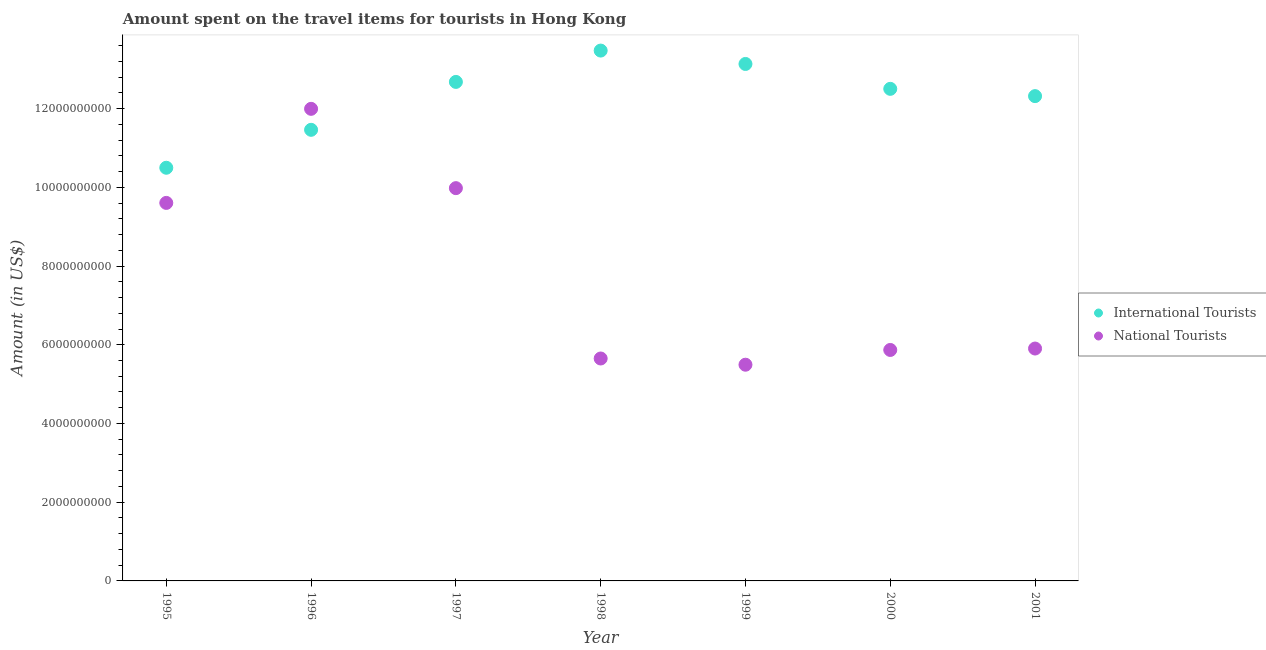How many different coloured dotlines are there?
Make the answer very short. 2. What is the amount spent on travel items of national tourists in 1998?
Give a very brief answer. 5.65e+09. Across all years, what is the maximum amount spent on travel items of national tourists?
Offer a very short reply. 1.20e+1. Across all years, what is the minimum amount spent on travel items of international tourists?
Offer a terse response. 1.05e+1. What is the total amount spent on travel items of international tourists in the graph?
Your answer should be compact. 8.61e+1. What is the difference between the amount spent on travel items of national tourists in 1996 and that in 2000?
Provide a short and direct response. 6.13e+09. What is the difference between the amount spent on travel items of national tourists in 2001 and the amount spent on travel items of international tourists in 1996?
Keep it short and to the point. -5.56e+09. What is the average amount spent on travel items of international tourists per year?
Keep it short and to the point. 1.23e+1. In the year 1999, what is the difference between the amount spent on travel items of national tourists and amount spent on travel items of international tourists?
Give a very brief answer. -7.64e+09. What is the ratio of the amount spent on travel items of international tourists in 1996 to that in 2000?
Provide a succinct answer. 0.92. Is the amount spent on travel items of international tourists in 1997 less than that in 1999?
Make the answer very short. Yes. What is the difference between the highest and the second highest amount spent on travel items of national tourists?
Give a very brief answer. 2.02e+09. What is the difference between the highest and the lowest amount spent on travel items of national tourists?
Your response must be concise. 6.50e+09. Is the sum of the amount spent on travel items of national tourists in 1995 and 1996 greater than the maximum amount spent on travel items of international tourists across all years?
Your response must be concise. Yes. Is the amount spent on travel items of national tourists strictly less than the amount spent on travel items of international tourists over the years?
Offer a terse response. No. How many years are there in the graph?
Your response must be concise. 7. What is the difference between two consecutive major ticks on the Y-axis?
Your response must be concise. 2.00e+09. Does the graph contain any zero values?
Make the answer very short. No. How many legend labels are there?
Your response must be concise. 2. What is the title of the graph?
Give a very brief answer. Amount spent on the travel items for tourists in Hong Kong. What is the Amount (in US$) in International Tourists in 1995?
Offer a very short reply. 1.05e+1. What is the Amount (in US$) in National Tourists in 1995?
Your answer should be compact. 9.60e+09. What is the Amount (in US$) in International Tourists in 1996?
Ensure brevity in your answer.  1.15e+1. What is the Amount (in US$) of National Tourists in 1996?
Keep it short and to the point. 1.20e+1. What is the Amount (in US$) in International Tourists in 1997?
Ensure brevity in your answer.  1.27e+1. What is the Amount (in US$) of National Tourists in 1997?
Provide a succinct answer. 9.98e+09. What is the Amount (in US$) of International Tourists in 1998?
Offer a terse response. 1.35e+1. What is the Amount (in US$) in National Tourists in 1998?
Ensure brevity in your answer.  5.65e+09. What is the Amount (in US$) of International Tourists in 1999?
Offer a terse response. 1.31e+1. What is the Amount (in US$) in National Tourists in 1999?
Make the answer very short. 5.49e+09. What is the Amount (in US$) of International Tourists in 2000?
Ensure brevity in your answer.  1.25e+1. What is the Amount (in US$) of National Tourists in 2000?
Keep it short and to the point. 5.87e+09. What is the Amount (in US$) in International Tourists in 2001?
Give a very brief answer. 1.23e+1. What is the Amount (in US$) of National Tourists in 2001?
Your answer should be compact. 5.90e+09. Across all years, what is the maximum Amount (in US$) of International Tourists?
Your answer should be very brief. 1.35e+1. Across all years, what is the maximum Amount (in US$) of National Tourists?
Your answer should be very brief. 1.20e+1. Across all years, what is the minimum Amount (in US$) in International Tourists?
Provide a short and direct response. 1.05e+1. Across all years, what is the minimum Amount (in US$) in National Tourists?
Give a very brief answer. 5.49e+09. What is the total Amount (in US$) of International Tourists in the graph?
Make the answer very short. 8.61e+1. What is the total Amount (in US$) in National Tourists in the graph?
Provide a succinct answer. 5.45e+1. What is the difference between the Amount (in US$) in International Tourists in 1995 and that in 1996?
Offer a very short reply. -9.64e+08. What is the difference between the Amount (in US$) in National Tourists in 1995 and that in 1996?
Keep it short and to the point. -2.39e+09. What is the difference between the Amount (in US$) in International Tourists in 1995 and that in 1997?
Keep it short and to the point. -2.18e+09. What is the difference between the Amount (in US$) of National Tourists in 1995 and that in 1997?
Your answer should be very brief. -3.75e+08. What is the difference between the Amount (in US$) of International Tourists in 1995 and that in 1998?
Your response must be concise. -2.98e+09. What is the difference between the Amount (in US$) of National Tourists in 1995 and that in 1998?
Your answer should be very brief. 3.95e+09. What is the difference between the Amount (in US$) in International Tourists in 1995 and that in 1999?
Keep it short and to the point. -2.64e+09. What is the difference between the Amount (in US$) of National Tourists in 1995 and that in 1999?
Your response must be concise. 4.11e+09. What is the difference between the Amount (in US$) of International Tourists in 1995 and that in 2000?
Make the answer very short. -2.00e+09. What is the difference between the Amount (in US$) of National Tourists in 1995 and that in 2000?
Your answer should be very brief. 3.74e+09. What is the difference between the Amount (in US$) of International Tourists in 1995 and that in 2001?
Provide a succinct answer. -1.82e+09. What is the difference between the Amount (in US$) in National Tourists in 1995 and that in 2001?
Keep it short and to the point. 3.70e+09. What is the difference between the Amount (in US$) in International Tourists in 1996 and that in 1997?
Your answer should be very brief. -1.22e+09. What is the difference between the Amount (in US$) of National Tourists in 1996 and that in 1997?
Make the answer very short. 2.02e+09. What is the difference between the Amount (in US$) of International Tourists in 1996 and that in 1998?
Offer a terse response. -2.01e+09. What is the difference between the Amount (in US$) in National Tourists in 1996 and that in 1998?
Offer a terse response. 6.34e+09. What is the difference between the Amount (in US$) of International Tourists in 1996 and that in 1999?
Your answer should be very brief. -1.67e+09. What is the difference between the Amount (in US$) of National Tourists in 1996 and that in 1999?
Provide a short and direct response. 6.50e+09. What is the difference between the Amount (in US$) in International Tourists in 1996 and that in 2000?
Your response must be concise. -1.04e+09. What is the difference between the Amount (in US$) in National Tourists in 1996 and that in 2000?
Your answer should be compact. 6.13e+09. What is the difference between the Amount (in US$) of International Tourists in 1996 and that in 2001?
Offer a terse response. -8.56e+08. What is the difference between the Amount (in US$) in National Tourists in 1996 and that in 2001?
Offer a terse response. 6.09e+09. What is the difference between the Amount (in US$) of International Tourists in 1997 and that in 1998?
Provide a short and direct response. -7.96e+08. What is the difference between the Amount (in US$) in National Tourists in 1997 and that in 1998?
Provide a short and direct response. 4.33e+09. What is the difference between the Amount (in US$) in International Tourists in 1997 and that in 1999?
Offer a terse response. -4.56e+08. What is the difference between the Amount (in US$) in National Tourists in 1997 and that in 1999?
Your response must be concise. 4.49e+09. What is the difference between the Amount (in US$) in International Tourists in 1997 and that in 2000?
Ensure brevity in your answer.  1.76e+08. What is the difference between the Amount (in US$) of National Tourists in 1997 and that in 2000?
Provide a succinct answer. 4.11e+09. What is the difference between the Amount (in US$) of International Tourists in 1997 and that in 2001?
Ensure brevity in your answer.  3.61e+08. What is the difference between the Amount (in US$) of National Tourists in 1997 and that in 2001?
Your response must be concise. 4.08e+09. What is the difference between the Amount (in US$) in International Tourists in 1998 and that in 1999?
Keep it short and to the point. 3.40e+08. What is the difference between the Amount (in US$) in National Tourists in 1998 and that in 1999?
Offer a very short reply. 1.58e+08. What is the difference between the Amount (in US$) of International Tourists in 1998 and that in 2000?
Provide a succinct answer. 9.72e+08. What is the difference between the Amount (in US$) in National Tourists in 1998 and that in 2000?
Ensure brevity in your answer.  -2.17e+08. What is the difference between the Amount (in US$) in International Tourists in 1998 and that in 2001?
Keep it short and to the point. 1.16e+09. What is the difference between the Amount (in US$) of National Tourists in 1998 and that in 2001?
Your response must be concise. -2.53e+08. What is the difference between the Amount (in US$) of International Tourists in 1999 and that in 2000?
Your answer should be compact. 6.32e+08. What is the difference between the Amount (in US$) in National Tourists in 1999 and that in 2000?
Give a very brief answer. -3.75e+08. What is the difference between the Amount (in US$) of International Tourists in 1999 and that in 2001?
Your response must be concise. 8.17e+08. What is the difference between the Amount (in US$) in National Tourists in 1999 and that in 2001?
Your answer should be very brief. -4.11e+08. What is the difference between the Amount (in US$) of International Tourists in 2000 and that in 2001?
Ensure brevity in your answer.  1.85e+08. What is the difference between the Amount (in US$) of National Tourists in 2000 and that in 2001?
Ensure brevity in your answer.  -3.60e+07. What is the difference between the Amount (in US$) of International Tourists in 1995 and the Amount (in US$) of National Tourists in 1996?
Your answer should be very brief. -1.50e+09. What is the difference between the Amount (in US$) of International Tourists in 1995 and the Amount (in US$) of National Tourists in 1997?
Your response must be concise. 5.18e+08. What is the difference between the Amount (in US$) in International Tourists in 1995 and the Amount (in US$) in National Tourists in 1998?
Ensure brevity in your answer.  4.85e+09. What is the difference between the Amount (in US$) in International Tourists in 1995 and the Amount (in US$) in National Tourists in 1999?
Keep it short and to the point. 5.00e+09. What is the difference between the Amount (in US$) of International Tourists in 1995 and the Amount (in US$) of National Tourists in 2000?
Offer a very short reply. 4.63e+09. What is the difference between the Amount (in US$) in International Tourists in 1995 and the Amount (in US$) in National Tourists in 2001?
Provide a short and direct response. 4.59e+09. What is the difference between the Amount (in US$) of International Tourists in 1996 and the Amount (in US$) of National Tourists in 1997?
Provide a succinct answer. 1.48e+09. What is the difference between the Amount (in US$) of International Tourists in 1996 and the Amount (in US$) of National Tourists in 1998?
Provide a succinct answer. 5.81e+09. What is the difference between the Amount (in US$) of International Tourists in 1996 and the Amount (in US$) of National Tourists in 1999?
Your response must be concise. 5.97e+09. What is the difference between the Amount (in US$) in International Tourists in 1996 and the Amount (in US$) in National Tourists in 2000?
Offer a very short reply. 5.59e+09. What is the difference between the Amount (in US$) of International Tourists in 1996 and the Amount (in US$) of National Tourists in 2001?
Keep it short and to the point. 5.56e+09. What is the difference between the Amount (in US$) in International Tourists in 1997 and the Amount (in US$) in National Tourists in 1998?
Offer a very short reply. 7.03e+09. What is the difference between the Amount (in US$) of International Tourists in 1997 and the Amount (in US$) of National Tourists in 1999?
Give a very brief answer. 7.18e+09. What is the difference between the Amount (in US$) of International Tourists in 1997 and the Amount (in US$) of National Tourists in 2000?
Ensure brevity in your answer.  6.81e+09. What is the difference between the Amount (in US$) in International Tourists in 1997 and the Amount (in US$) in National Tourists in 2001?
Provide a succinct answer. 6.77e+09. What is the difference between the Amount (in US$) of International Tourists in 1998 and the Amount (in US$) of National Tourists in 1999?
Make the answer very short. 7.98e+09. What is the difference between the Amount (in US$) in International Tourists in 1998 and the Amount (in US$) in National Tourists in 2000?
Provide a succinct answer. 7.61e+09. What is the difference between the Amount (in US$) of International Tourists in 1998 and the Amount (in US$) of National Tourists in 2001?
Ensure brevity in your answer.  7.57e+09. What is the difference between the Amount (in US$) in International Tourists in 1999 and the Amount (in US$) in National Tourists in 2000?
Give a very brief answer. 7.27e+09. What is the difference between the Amount (in US$) in International Tourists in 1999 and the Amount (in US$) in National Tourists in 2001?
Your answer should be compact. 7.23e+09. What is the difference between the Amount (in US$) of International Tourists in 2000 and the Amount (in US$) of National Tourists in 2001?
Offer a very short reply. 6.60e+09. What is the average Amount (in US$) in International Tourists per year?
Your answer should be very brief. 1.23e+1. What is the average Amount (in US$) in National Tourists per year?
Your answer should be very brief. 7.78e+09. In the year 1995, what is the difference between the Amount (in US$) of International Tourists and Amount (in US$) of National Tourists?
Your response must be concise. 8.93e+08. In the year 1996, what is the difference between the Amount (in US$) of International Tourists and Amount (in US$) of National Tourists?
Offer a terse response. -5.33e+08. In the year 1997, what is the difference between the Amount (in US$) in International Tourists and Amount (in US$) in National Tourists?
Your response must be concise. 2.70e+09. In the year 1998, what is the difference between the Amount (in US$) in International Tourists and Amount (in US$) in National Tourists?
Your answer should be very brief. 7.82e+09. In the year 1999, what is the difference between the Amount (in US$) of International Tourists and Amount (in US$) of National Tourists?
Keep it short and to the point. 7.64e+09. In the year 2000, what is the difference between the Amount (in US$) of International Tourists and Amount (in US$) of National Tourists?
Your answer should be compact. 6.63e+09. In the year 2001, what is the difference between the Amount (in US$) of International Tourists and Amount (in US$) of National Tourists?
Offer a very short reply. 6.41e+09. What is the ratio of the Amount (in US$) in International Tourists in 1995 to that in 1996?
Provide a short and direct response. 0.92. What is the ratio of the Amount (in US$) of National Tourists in 1995 to that in 1996?
Ensure brevity in your answer.  0.8. What is the ratio of the Amount (in US$) in International Tourists in 1995 to that in 1997?
Keep it short and to the point. 0.83. What is the ratio of the Amount (in US$) of National Tourists in 1995 to that in 1997?
Your answer should be very brief. 0.96. What is the ratio of the Amount (in US$) in International Tourists in 1995 to that in 1998?
Your answer should be compact. 0.78. What is the ratio of the Amount (in US$) of National Tourists in 1995 to that in 1998?
Your answer should be very brief. 1.7. What is the ratio of the Amount (in US$) in International Tourists in 1995 to that in 1999?
Provide a short and direct response. 0.8. What is the ratio of the Amount (in US$) of National Tourists in 1995 to that in 1999?
Give a very brief answer. 1.75. What is the ratio of the Amount (in US$) of International Tourists in 1995 to that in 2000?
Your response must be concise. 0.84. What is the ratio of the Amount (in US$) in National Tourists in 1995 to that in 2000?
Offer a very short reply. 1.64. What is the ratio of the Amount (in US$) in International Tourists in 1995 to that in 2001?
Ensure brevity in your answer.  0.85. What is the ratio of the Amount (in US$) of National Tourists in 1995 to that in 2001?
Provide a succinct answer. 1.63. What is the ratio of the Amount (in US$) of International Tourists in 1996 to that in 1997?
Your answer should be compact. 0.9. What is the ratio of the Amount (in US$) in National Tourists in 1996 to that in 1997?
Provide a succinct answer. 1.2. What is the ratio of the Amount (in US$) in International Tourists in 1996 to that in 1998?
Ensure brevity in your answer.  0.85. What is the ratio of the Amount (in US$) in National Tourists in 1996 to that in 1998?
Offer a terse response. 2.12. What is the ratio of the Amount (in US$) of International Tourists in 1996 to that in 1999?
Your answer should be very brief. 0.87. What is the ratio of the Amount (in US$) in National Tourists in 1996 to that in 1999?
Ensure brevity in your answer.  2.18. What is the ratio of the Amount (in US$) of National Tourists in 1996 to that in 2000?
Your response must be concise. 2.04. What is the ratio of the Amount (in US$) of International Tourists in 1996 to that in 2001?
Provide a short and direct response. 0.93. What is the ratio of the Amount (in US$) in National Tourists in 1996 to that in 2001?
Your answer should be very brief. 2.03. What is the ratio of the Amount (in US$) of International Tourists in 1997 to that in 1998?
Keep it short and to the point. 0.94. What is the ratio of the Amount (in US$) in National Tourists in 1997 to that in 1998?
Provide a short and direct response. 1.77. What is the ratio of the Amount (in US$) in International Tourists in 1997 to that in 1999?
Give a very brief answer. 0.97. What is the ratio of the Amount (in US$) in National Tourists in 1997 to that in 1999?
Your answer should be compact. 1.82. What is the ratio of the Amount (in US$) of International Tourists in 1997 to that in 2000?
Provide a short and direct response. 1.01. What is the ratio of the Amount (in US$) of National Tourists in 1997 to that in 2000?
Keep it short and to the point. 1.7. What is the ratio of the Amount (in US$) of International Tourists in 1997 to that in 2001?
Keep it short and to the point. 1.03. What is the ratio of the Amount (in US$) of National Tourists in 1997 to that in 2001?
Give a very brief answer. 1.69. What is the ratio of the Amount (in US$) in International Tourists in 1998 to that in 1999?
Provide a short and direct response. 1.03. What is the ratio of the Amount (in US$) in National Tourists in 1998 to that in 1999?
Offer a very short reply. 1.03. What is the ratio of the Amount (in US$) in International Tourists in 1998 to that in 2000?
Keep it short and to the point. 1.08. What is the ratio of the Amount (in US$) in National Tourists in 1998 to that in 2000?
Your response must be concise. 0.96. What is the ratio of the Amount (in US$) in International Tourists in 1998 to that in 2001?
Provide a succinct answer. 1.09. What is the ratio of the Amount (in US$) in National Tourists in 1998 to that in 2001?
Your response must be concise. 0.96. What is the ratio of the Amount (in US$) of International Tourists in 1999 to that in 2000?
Provide a short and direct response. 1.05. What is the ratio of the Amount (in US$) in National Tourists in 1999 to that in 2000?
Your answer should be very brief. 0.94. What is the ratio of the Amount (in US$) in International Tourists in 1999 to that in 2001?
Your answer should be very brief. 1.07. What is the ratio of the Amount (in US$) in National Tourists in 1999 to that in 2001?
Provide a short and direct response. 0.93. What is the ratio of the Amount (in US$) in International Tourists in 2000 to that in 2001?
Ensure brevity in your answer.  1.01. What is the difference between the highest and the second highest Amount (in US$) of International Tourists?
Offer a very short reply. 3.40e+08. What is the difference between the highest and the second highest Amount (in US$) in National Tourists?
Provide a succinct answer. 2.02e+09. What is the difference between the highest and the lowest Amount (in US$) in International Tourists?
Provide a succinct answer. 2.98e+09. What is the difference between the highest and the lowest Amount (in US$) in National Tourists?
Provide a succinct answer. 6.50e+09. 